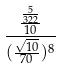Convert formula to latex. <formula><loc_0><loc_0><loc_500><loc_500>\frac { \frac { \frac { 5 } { 3 2 2 } } { 1 0 } } { ( \frac { \sqrt { 1 0 } } { 7 0 } ) ^ { 8 } }</formula> 